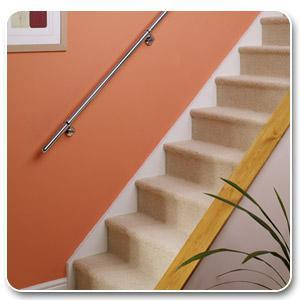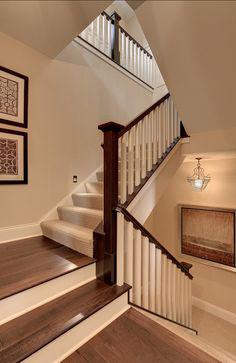The first image is the image on the left, the second image is the image on the right. Evaluate the accuracy of this statement regarding the images: "The plant in the image on the left is sitting beside the stairway.". Is it true? Answer yes or no. Yes. 